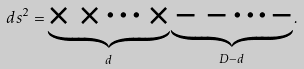Convert formula to latex. <formula><loc_0><loc_0><loc_500><loc_500>d s ^ { 2 } = \underbrace { \times \, \times \cdots \, \times } _ { d } \underbrace { \, - \, - \cdots - } _ { D - d } .</formula> 